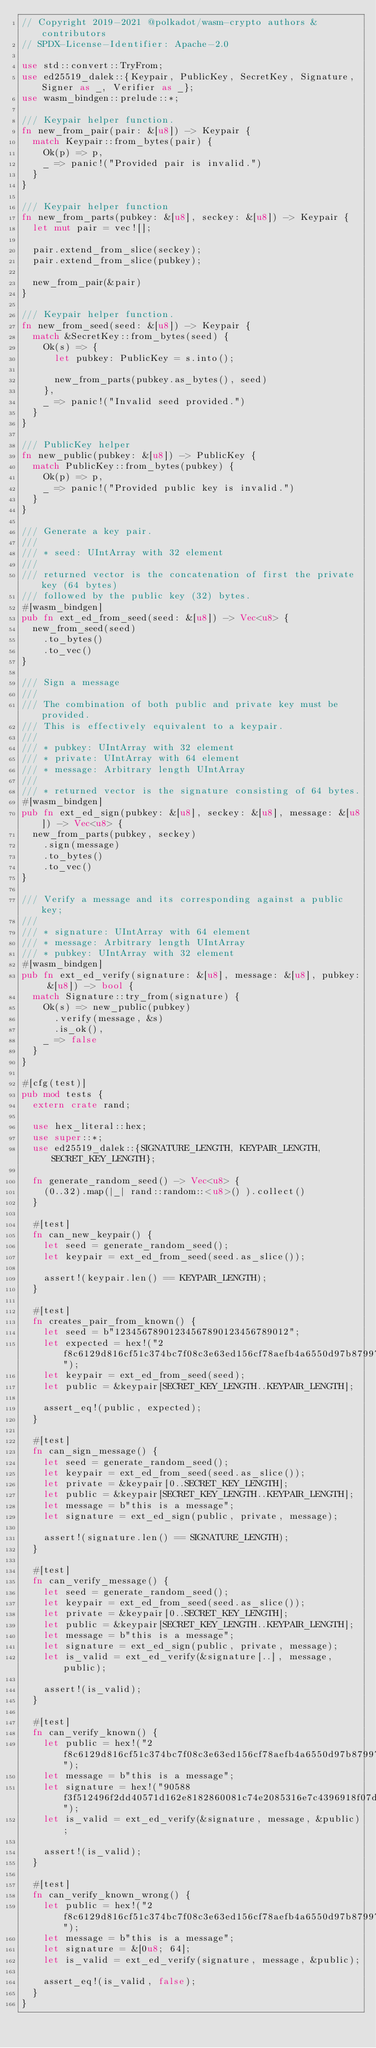<code> <loc_0><loc_0><loc_500><loc_500><_Rust_>// Copyright 2019-2021 @polkadot/wasm-crypto authors & contributors
// SPDX-License-Identifier: Apache-2.0

use std::convert::TryFrom;
use ed25519_dalek::{Keypair, PublicKey, SecretKey, Signature, Signer as _, Verifier as _};
use wasm_bindgen::prelude::*;

/// Keypair helper function.
fn new_from_pair(pair: &[u8]) -> Keypair {
	match Keypair::from_bytes(pair) {
		Ok(p) => p,
		_ => panic!("Provided pair is invalid.")
	}
}

/// Keypair helper function
fn new_from_parts(pubkey: &[u8], seckey: &[u8]) -> Keypair {
	let mut pair = vec![];

	pair.extend_from_slice(seckey);
	pair.extend_from_slice(pubkey);

	new_from_pair(&pair)
}

/// Keypair helper function.
fn new_from_seed(seed: &[u8]) -> Keypair {
	match &SecretKey::from_bytes(seed) {
		Ok(s) => {
			let pubkey: PublicKey = s.into();

			new_from_parts(pubkey.as_bytes(), seed)
		},
		_ => panic!("Invalid seed provided.")
	}
}

/// PublicKey helper
fn new_public(pubkey: &[u8]) -> PublicKey {
	match PublicKey::from_bytes(pubkey) {
		Ok(p) => p,
		_ => panic!("Provided public key is invalid.")
	}
}

/// Generate a key pair.
///
/// * seed: UIntArray with 32 element
///
/// returned vector is the concatenation of first the private key (64 bytes)
/// followed by the public key (32) bytes.
#[wasm_bindgen]
pub fn ext_ed_from_seed(seed: &[u8]) -> Vec<u8> {
	new_from_seed(seed)
		.to_bytes()
		.to_vec()
}

/// Sign a message
///
/// The combination of both public and private key must be provided.
/// This is effectively equivalent to a keypair.
///
/// * pubkey: UIntArray with 32 element
/// * private: UIntArray with 64 element
/// * message: Arbitrary length UIntArray
///
/// * returned vector is the signature consisting of 64 bytes.
#[wasm_bindgen]
pub fn ext_ed_sign(pubkey: &[u8], seckey: &[u8], message: &[u8]) -> Vec<u8> {
	new_from_parts(pubkey, seckey)
		.sign(message)
		.to_bytes()
		.to_vec()
}

/// Verify a message and its corresponding against a public key;
///
/// * signature: UIntArray with 64 element
/// * message: Arbitrary length UIntArray
/// * pubkey: UIntArray with 32 element
#[wasm_bindgen]
pub fn ext_ed_verify(signature: &[u8], message: &[u8], pubkey: &[u8]) -> bool {
	match Signature::try_from(signature) {
		Ok(s) => new_public(pubkey)
			.verify(message, &s)
			.is_ok(),
		_ => false
	}
}

#[cfg(test)]
pub mod tests {
	extern crate rand;

	use hex_literal::hex;
	use super::*;
	use ed25519_dalek::{SIGNATURE_LENGTH, KEYPAIR_LENGTH, SECRET_KEY_LENGTH};

	fn generate_random_seed() -> Vec<u8> {
		(0..32).map(|_| rand::random::<u8>() ).collect()
	}

	#[test]
	fn can_new_keypair() {
		let seed = generate_random_seed();
		let keypair = ext_ed_from_seed(seed.as_slice());

		assert!(keypair.len() == KEYPAIR_LENGTH);
	}

	#[test]
	fn creates_pair_from_known() {
		let seed = b"12345678901234567890123456789012";
		let expected = hex!("2f8c6129d816cf51c374bc7f08c3e63ed156cf78aefb4a6550d97b87997977ee");
		let keypair = ext_ed_from_seed(seed);
		let public = &keypair[SECRET_KEY_LENGTH..KEYPAIR_LENGTH];

		assert_eq!(public, expected);
	}

	#[test]
	fn can_sign_message() {
		let seed = generate_random_seed();
		let keypair = ext_ed_from_seed(seed.as_slice());
		let private = &keypair[0..SECRET_KEY_LENGTH];
		let public = &keypair[SECRET_KEY_LENGTH..KEYPAIR_LENGTH];
		let message = b"this is a message";
		let signature = ext_ed_sign(public, private, message);

		assert!(signature.len() == SIGNATURE_LENGTH);
	}

	#[test]
	fn can_verify_message() {
		let seed = generate_random_seed();
		let keypair = ext_ed_from_seed(seed.as_slice());
		let private = &keypair[0..SECRET_KEY_LENGTH];
		let public = &keypair[SECRET_KEY_LENGTH..KEYPAIR_LENGTH];
		let message = b"this is a message";
		let signature = ext_ed_sign(public, private, message);
		let is_valid = ext_ed_verify(&signature[..], message, public);

		assert!(is_valid);
	}

	#[test]
	fn can_verify_known() {
		let public = hex!("2f8c6129d816cf51c374bc7f08c3e63ed156cf78aefb4a6550d97b87997977ee");
		let message = b"this is a message";
		let signature = hex!("90588f3f512496f2dd40571d162e8182860081c74e2085316e7c4396918f07da412ee029978e4dd714057fe973bd9e7d645148bf7b66680d67c93227cde95202");
		let is_valid = ext_ed_verify(&signature, message, &public);

		assert!(is_valid);
	}

	#[test]
	fn can_verify_known_wrong() {
		let public = hex!("2f8c6129d816cf51c374bc7f08c3e63ed156cf78aefb4a6550d97b87997977ee");
		let message = b"this is a message";
		let signature = &[0u8; 64];
		let is_valid = ext_ed_verify(signature, message, &public);

		assert_eq!(is_valid, false);
	}
}
</code> 